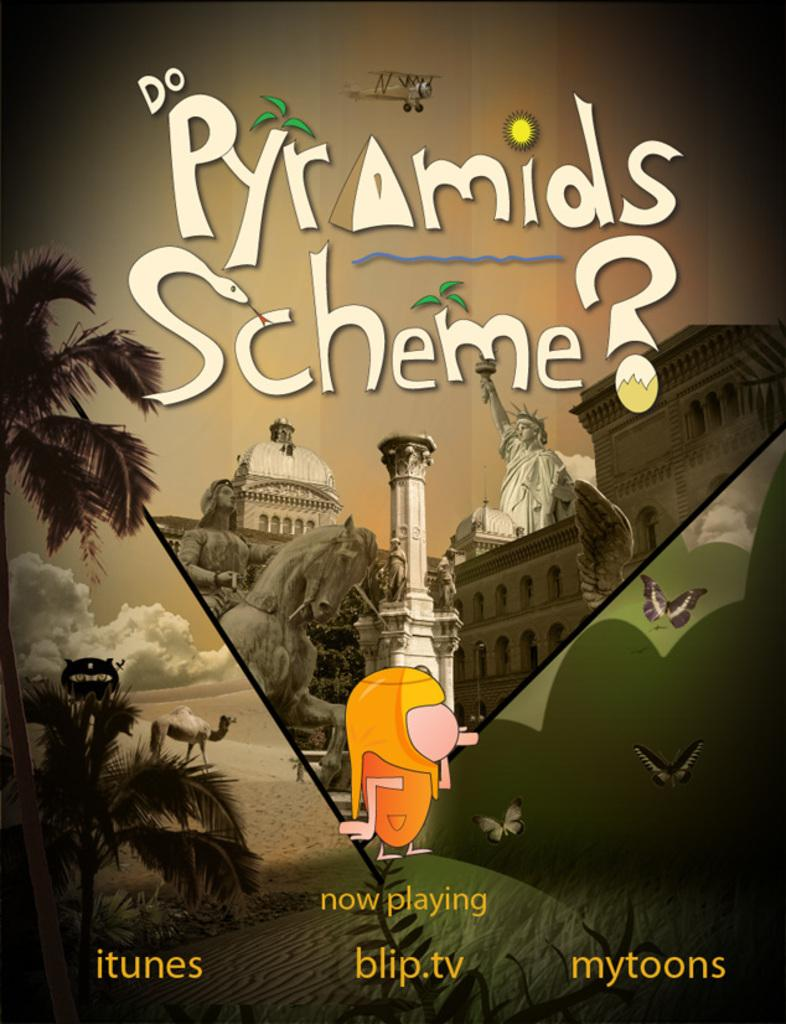Provide a one-sentence caption for the provided image. a itunes blip.tv mytoons advertisement entitled Do Pyramids Scheme? with statues and other graphics. 